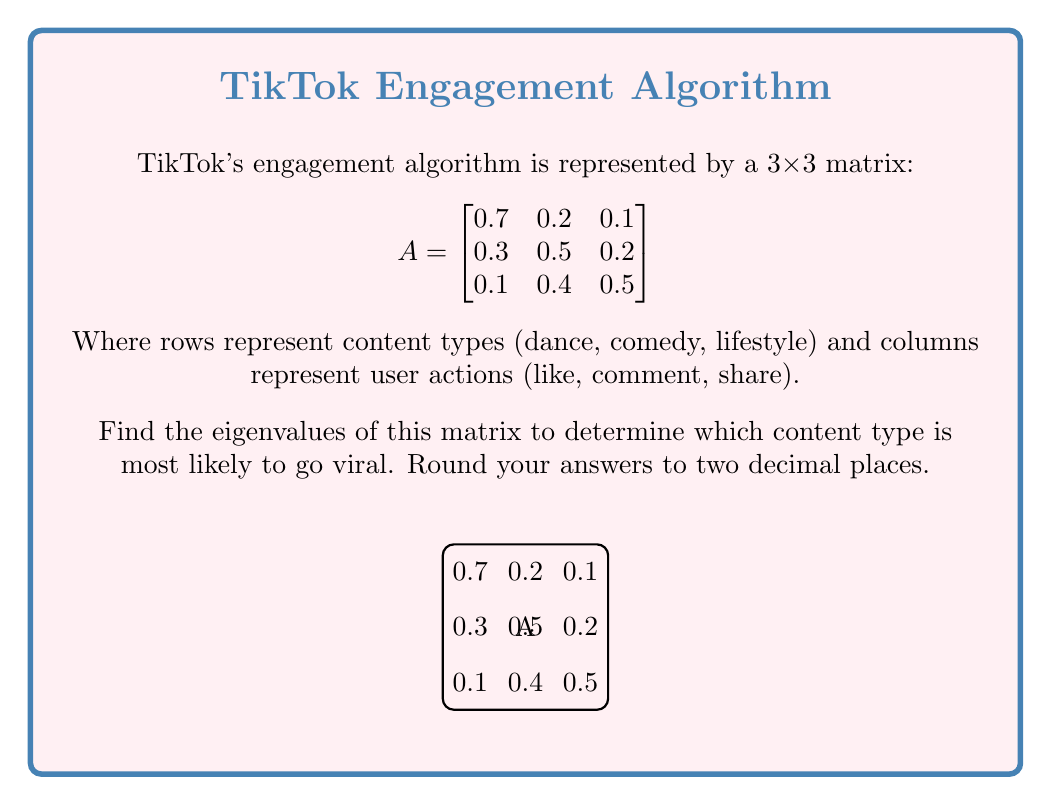Give your solution to this math problem. To find the eigenvalues of matrix A, we need to solve the characteristic equation:

$$det(A - \lambda I) = 0$$

Where $I$ is the 3x3 identity matrix and $\lambda$ represents the eigenvalues.

Step 1: Set up the characteristic equation
$$det\begin{pmatrix}
0.7-\lambda & 0.2 & 0.1 \\
0.3 & 0.5-\lambda & 0.2 \\
0.1 & 0.4 & 0.5-\lambda
\end{pmatrix} = 0$$

Step 2: Expand the determinant
$$(0.7-\lambda)[(0.5-\lambda)(0.5-\lambda) - 0.08] - 0.2[0.3(0.5-\lambda) - 0.02] + 0.1[0.12 - 0.4(0.5-\lambda)] = 0$$

Step 3: Simplify
$$(0.7-\lambda)[(0.25-0.5\lambda+\lambda^2) - 0.08] - 0.2[0.15-0.3\lambda - 0.02] + 0.1[0.12 - 0.2+0.4\lambda] = 0$$
$$(0.7-\lambda)(0.17-0.5\lambda+\lambda^2) - 0.2(0.13-0.3\lambda) + 0.1(-0.08+0.4\lambda) = 0$$

Step 4: Expand and collect terms
$$-\lambda^3 + 1.7\lambda^2 - 0.84\lambda + 0.119 = 0$$

Step 5: Solve the cubic equation
Using a cubic equation solver or numerical methods, we find the roots:

$\lambda_1 \approx 1.00$
$\lambda_2 \approx 0.39$
$\lambda_3 \approx 0.31$

Rounding to two decimal places gives us the final answer.
Answer: 1.00, 0.39, 0.31 